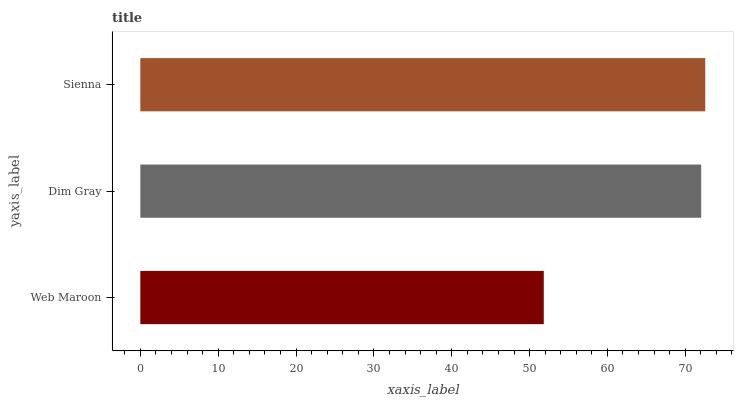Is Web Maroon the minimum?
Answer yes or no. Yes. Is Sienna the maximum?
Answer yes or no. Yes. Is Dim Gray the minimum?
Answer yes or no. No. Is Dim Gray the maximum?
Answer yes or no. No. Is Dim Gray greater than Web Maroon?
Answer yes or no. Yes. Is Web Maroon less than Dim Gray?
Answer yes or no. Yes. Is Web Maroon greater than Dim Gray?
Answer yes or no. No. Is Dim Gray less than Web Maroon?
Answer yes or no. No. Is Dim Gray the high median?
Answer yes or no. Yes. Is Dim Gray the low median?
Answer yes or no. Yes. Is Web Maroon the high median?
Answer yes or no. No. Is Sienna the low median?
Answer yes or no. No. 